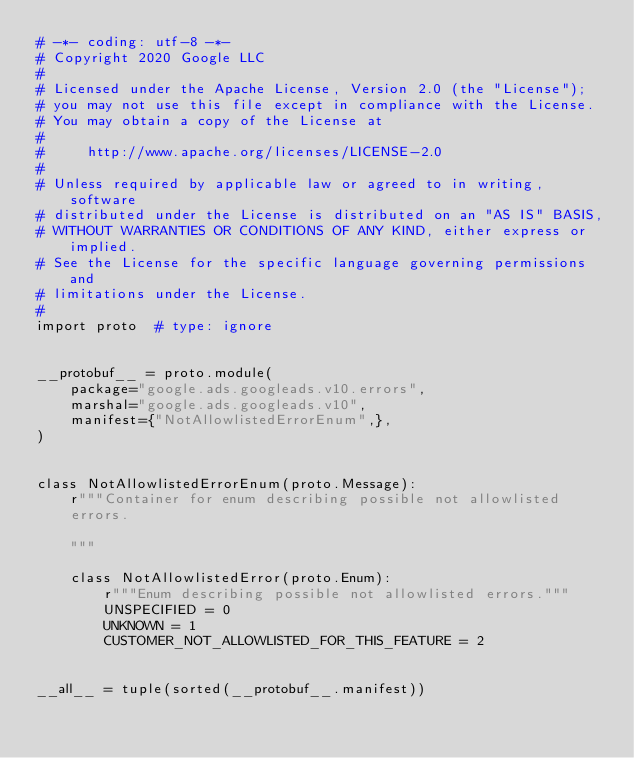Convert code to text. <code><loc_0><loc_0><loc_500><loc_500><_Python_># -*- coding: utf-8 -*-
# Copyright 2020 Google LLC
#
# Licensed under the Apache License, Version 2.0 (the "License");
# you may not use this file except in compliance with the License.
# You may obtain a copy of the License at
#
#     http://www.apache.org/licenses/LICENSE-2.0
#
# Unless required by applicable law or agreed to in writing, software
# distributed under the License is distributed on an "AS IS" BASIS,
# WITHOUT WARRANTIES OR CONDITIONS OF ANY KIND, either express or implied.
# See the License for the specific language governing permissions and
# limitations under the License.
#
import proto  # type: ignore


__protobuf__ = proto.module(
    package="google.ads.googleads.v10.errors",
    marshal="google.ads.googleads.v10",
    manifest={"NotAllowlistedErrorEnum",},
)


class NotAllowlistedErrorEnum(proto.Message):
    r"""Container for enum describing possible not allowlisted
    errors.

    """

    class NotAllowlistedError(proto.Enum):
        r"""Enum describing possible not allowlisted errors."""
        UNSPECIFIED = 0
        UNKNOWN = 1
        CUSTOMER_NOT_ALLOWLISTED_FOR_THIS_FEATURE = 2


__all__ = tuple(sorted(__protobuf__.manifest))
</code> 